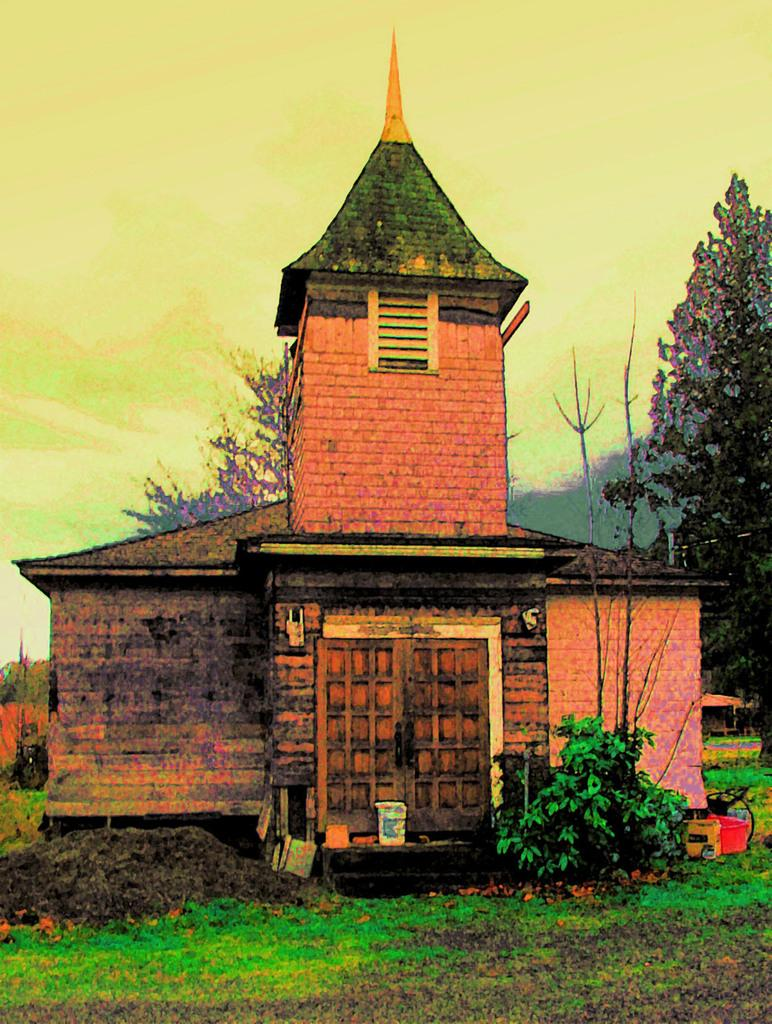What is depicted in the painting in the image? There is a painting of a building in the image. What features can be seen on the building in the painting? The building in the painting has a door and a window. What type of vegetation is visible in the image? There is grass, plants, and trees visible in the image. What is the condition of the sky in the image? The sky is clear in the image. What type of music can be heard playing from the zinc in the image? There is no zinc or music present in the image; it features a painting of a building with a door and a window, along with vegetation and a clear sky. 